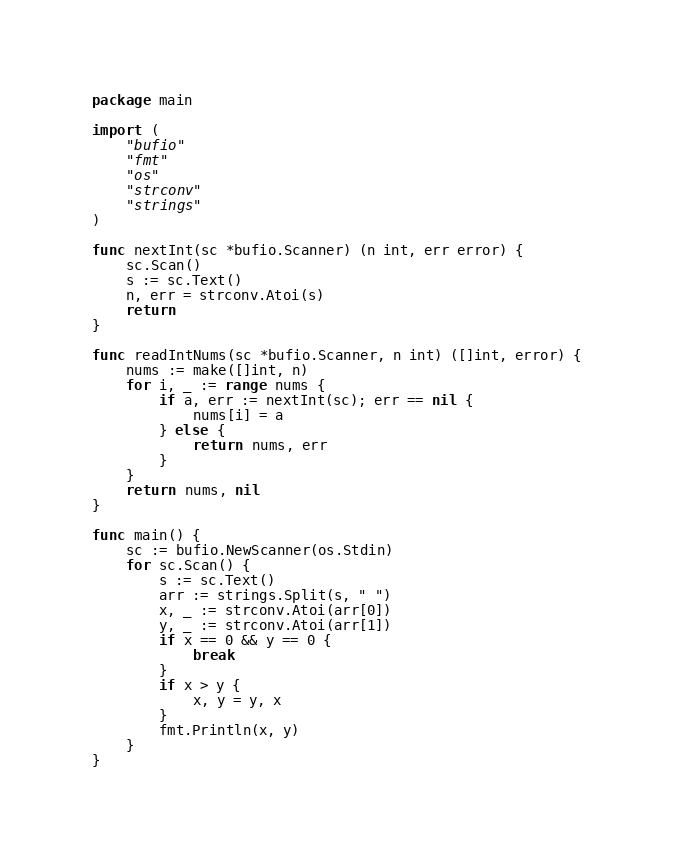<code> <loc_0><loc_0><loc_500><loc_500><_Go_>package main

import (
	"bufio"
	"fmt"
	"os"
	"strconv"
	"strings"
)

func nextInt(sc *bufio.Scanner) (n int, err error) {
	sc.Scan()
	s := sc.Text()
	n, err = strconv.Atoi(s)
	return
}

func readIntNums(sc *bufio.Scanner, n int) ([]int, error) {
	nums := make([]int, n)
	for i, _ := range nums {
		if a, err := nextInt(sc); err == nil {
			nums[i] = a
		} else {
			return nums, err
		}
	}
	return nums, nil
}

func main() {
	sc := bufio.NewScanner(os.Stdin)
	for sc.Scan() {
		s := sc.Text()
		arr := strings.Split(s, " ")
		x, _ := strconv.Atoi(arr[0])
		y, _ := strconv.Atoi(arr[1])
		if x == 0 && y == 0 {
			break
		}
		if x > y {
			x, y = y, x
		}
		fmt.Println(x, y)
	}
}

</code> 